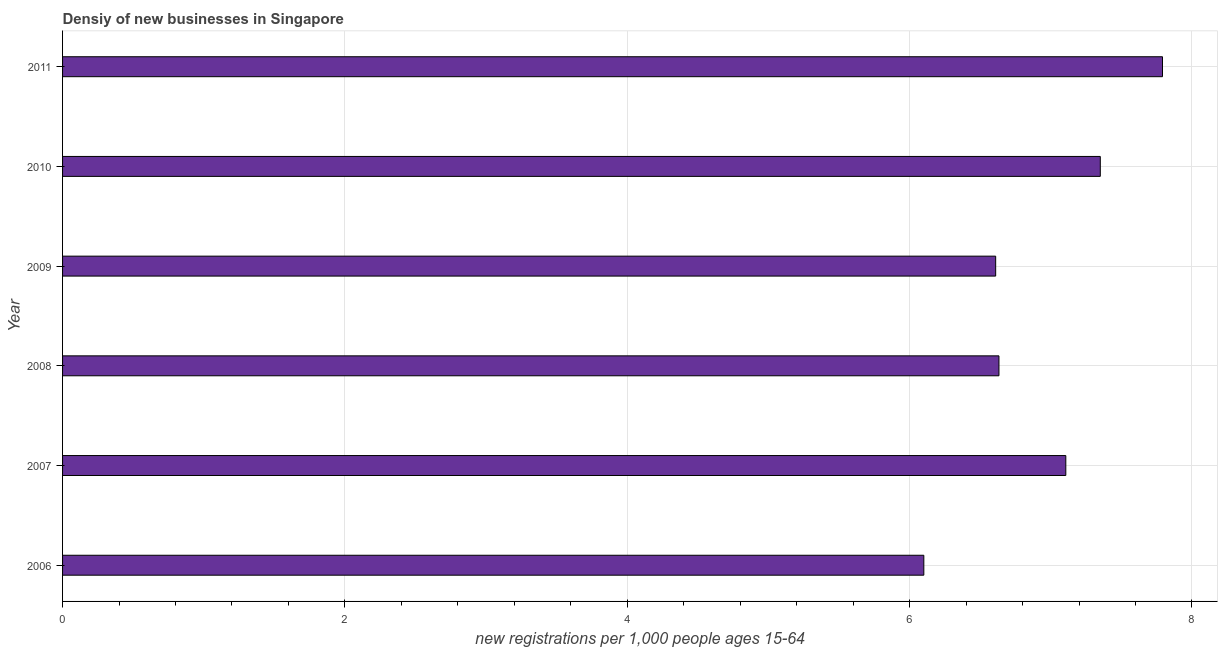Does the graph contain grids?
Ensure brevity in your answer.  Yes. What is the title of the graph?
Provide a short and direct response. Densiy of new businesses in Singapore. What is the label or title of the X-axis?
Provide a succinct answer. New registrations per 1,0 people ages 15-64. What is the label or title of the Y-axis?
Make the answer very short. Year. What is the density of new business in 2008?
Your answer should be very brief. 6.63. Across all years, what is the maximum density of new business?
Offer a very short reply. 7.79. Across all years, what is the minimum density of new business?
Provide a succinct answer. 6.1. In which year was the density of new business maximum?
Offer a terse response. 2011. In which year was the density of new business minimum?
Your answer should be very brief. 2006. What is the sum of the density of new business?
Ensure brevity in your answer.  41.59. What is the difference between the density of new business in 2006 and 2010?
Offer a terse response. -1.25. What is the average density of new business per year?
Your answer should be very brief. 6.93. What is the median density of new business?
Give a very brief answer. 6.87. In how many years, is the density of new business greater than 0.4 ?
Make the answer very short. 6. Do a majority of the years between 2009 and 2006 (inclusive) have density of new business greater than 6.8 ?
Your answer should be very brief. Yes. Is the difference between the density of new business in 2009 and 2010 greater than the difference between any two years?
Make the answer very short. No. What is the difference between the highest and the second highest density of new business?
Ensure brevity in your answer.  0.44. Is the sum of the density of new business in 2006 and 2007 greater than the maximum density of new business across all years?
Keep it short and to the point. Yes. What is the difference between the highest and the lowest density of new business?
Your response must be concise. 1.69. In how many years, is the density of new business greater than the average density of new business taken over all years?
Provide a succinct answer. 3. What is the difference between two consecutive major ticks on the X-axis?
Give a very brief answer. 2. Are the values on the major ticks of X-axis written in scientific E-notation?
Your answer should be compact. No. What is the new registrations per 1,000 people ages 15-64 in 2006?
Give a very brief answer. 6.1. What is the new registrations per 1,000 people ages 15-64 in 2007?
Offer a terse response. 7.11. What is the new registrations per 1,000 people ages 15-64 of 2008?
Offer a terse response. 6.63. What is the new registrations per 1,000 people ages 15-64 of 2009?
Provide a succinct answer. 6.61. What is the new registrations per 1,000 people ages 15-64 of 2010?
Offer a very short reply. 7.35. What is the new registrations per 1,000 people ages 15-64 of 2011?
Offer a very short reply. 7.79. What is the difference between the new registrations per 1,000 people ages 15-64 in 2006 and 2007?
Make the answer very short. -1.01. What is the difference between the new registrations per 1,000 people ages 15-64 in 2006 and 2008?
Provide a succinct answer. -0.53. What is the difference between the new registrations per 1,000 people ages 15-64 in 2006 and 2009?
Your answer should be compact. -0.51. What is the difference between the new registrations per 1,000 people ages 15-64 in 2006 and 2010?
Provide a short and direct response. -1.25. What is the difference between the new registrations per 1,000 people ages 15-64 in 2006 and 2011?
Your answer should be very brief. -1.69. What is the difference between the new registrations per 1,000 people ages 15-64 in 2007 and 2008?
Ensure brevity in your answer.  0.47. What is the difference between the new registrations per 1,000 people ages 15-64 in 2007 and 2009?
Ensure brevity in your answer.  0.5. What is the difference between the new registrations per 1,000 people ages 15-64 in 2007 and 2010?
Your response must be concise. -0.24. What is the difference between the new registrations per 1,000 people ages 15-64 in 2007 and 2011?
Offer a very short reply. -0.68. What is the difference between the new registrations per 1,000 people ages 15-64 in 2008 and 2009?
Ensure brevity in your answer.  0.02. What is the difference between the new registrations per 1,000 people ages 15-64 in 2008 and 2010?
Make the answer very short. -0.72. What is the difference between the new registrations per 1,000 people ages 15-64 in 2008 and 2011?
Keep it short and to the point. -1.16. What is the difference between the new registrations per 1,000 people ages 15-64 in 2009 and 2010?
Your answer should be compact. -0.74. What is the difference between the new registrations per 1,000 people ages 15-64 in 2009 and 2011?
Ensure brevity in your answer.  -1.18. What is the difference between the new registrations per 1,000 people ages 15-64 in 2010 and 2011?
Provide a short and direct response. -0.44. What is the ratio of the new registrations per 1,000 people ages 15-64 in 2006 to that in 2007?
Your answer should be compact. 0.86. What is the ratio of the new registrations per 1,000 people ages 15-64 in 2006 to that in 2008?
Offer a very short reply. 0.92. What is the ratio of the new registrations per 1,000 people ages 15-64 in 2006 to that in 2009?
Your answer should be compact. 0.92. What is the ratio of the new registrations per 1,000 people ages 15-64 in 2006 to that in 2010?
Provide a short and direct response. 0.83. What is the ratio of the new registrations per 1,000 people ages 15-64 in 2006 to that in 2011?
Provide a short and direct response. 0.78. What is the ratio of the new registrations per 1,000 people ages 15-64 in 2007 to that in 2008?
Give a very brief answer. 1.07. What is the ratio of the new registrations per 1,000 people ages 15-64 in 2007 to that in 2009?
Your answer should be compact. 1.07. What is the ratio of the new registrations per 1,000 people ages 15-64 in 2007 to that in 2010?
Your response must be concise. 0.97. What is the ratio of the new registrations per 1,000 people ages 15-64 in 2007 to that in 2011?
Make the answer very short. 0.91. What is the ratio of the new registrations per 1,000 people ages 15-64 in 2008 to that in 2009?
Ensure brevity in your answer.  1. What is the ratio of the new registrations per 1,000 people ages 15-64 in 2008 to that in 2010?
Offer a terse response. 0.9. What is the ratio of the new registrations per 1,000 people ages 15-64 in 2008 to that in 2011?
Ensure brevity in your answer.  0.85. What is the ratio of the new registrations per 1,000 people ages 15-64 in 2009 to that in 2010?
Keep it short and to the point. 0.9. What is the ratio of the new registrations per 1,000 people ages 15-64 in 2009 to that in 2011?
Provide a short and direct response. 0.85. What is the ratio of the new registrations per 1,000 people ages 15-64 in 2010 to that in 2011?
Your answer should be very brief. 0.94. 